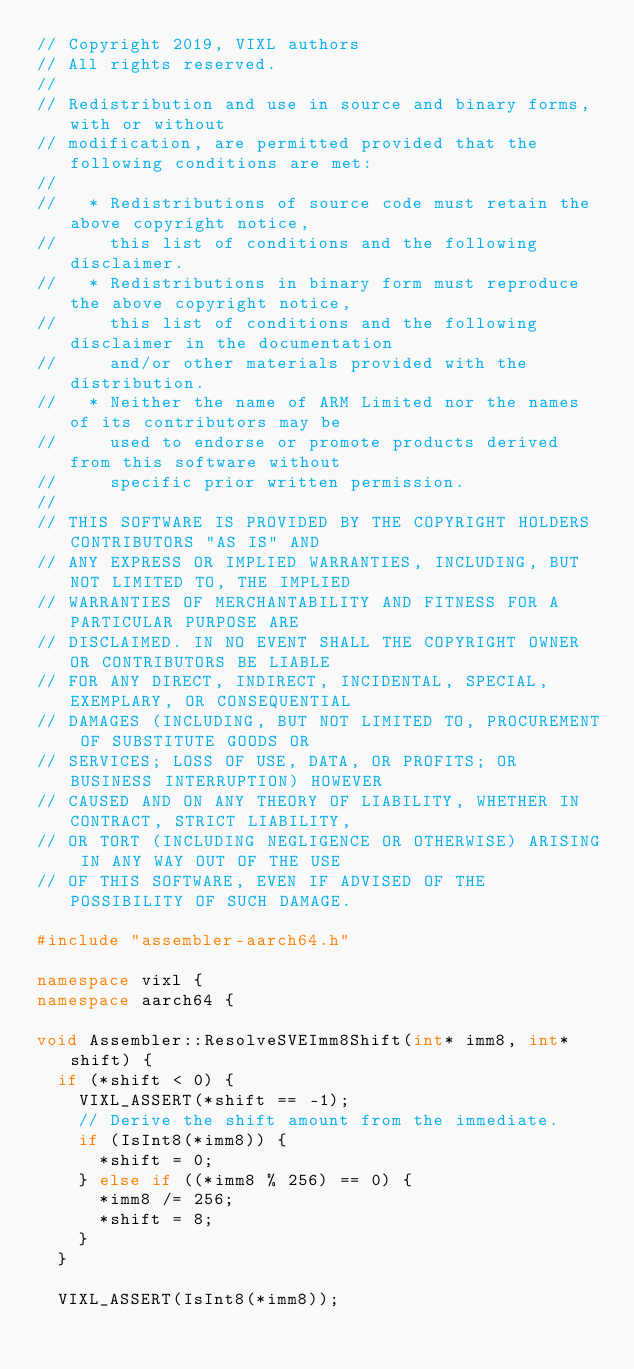<code> <loc_0><loc_0><loc_500><loc_500><_C++_>// Copyright 2019, VIXL authors
// All rights reserved.
//
// Redistribution and use in source and binary forms, with or without
// modification, are permitted provided that the following conditions are met:
//
//   * Redistributions of source code must retain the above copyright notice,
//     this list of conditions and the following disclaimer.
//   * Redistributions in binary form must reproduce the above copyright notice,
//     this list of conditions and the following disclaimer in the documentation
//     and/or other materials provided with the distribution.
//   * Neither the name of ARM Limited nor the names of its contributors may be
//     used to endorse or promote products derived from this software without
//     specific prior written permission.
//
// THIS SOFTWARE IS PROVIDED BY THE COPYRIGHT HOLDERS CONTRIBUTORS "AS IS" AND
// ANY EXPRESS OR IMPLIED WARRANTIES, INCLUDING, BUT NOT LIMITED TO, THE IMPLIED
// WARRANTIES OF MERCHANTABILITY AND FITNESS FOR A PARTICULAR PURPOSE ARE
// DISCLAIMED. IN NO EVENT SHALL THE COPYRIGHT OWNER OR CONTRIBUTORS BE LIABLE
// FOR ANY DIRECT, INDIRECT, INCIDENTAL, SPECIAL, EXEMPLARY, OR CONSEQUENTIAL
// DAMAGES (INCLUDING, BUT NOT LIMITED TO, PROCUREMENT OF SUBSTITUTE GOODS OR
// SERVICES; LOSS OF USE, DATA, OR PROFITS; OR BUSINESS INTERRUPTION) HOWEVER
// CAUSED AND ON ANY THEORY OF LIABILITY, WHETHER IN CONTRACT, STRICT LIABILITY,
// OR TORT (INCLUDING NEGLIGENCE OR OTHERWISE) ARISING IN ANY WAY OUT OF THE USE
// OF THIS SOFTWARE, EVEN IF ADVISED OF THE POSSIBILITY OF SUCH DAMAGE.

#include "assembler-aarch64.h"

namespace vixl {
namespace aarch64 {

void Assembler::ResolveSVEImm8Shift(int* imm8, int* shift) {
  if (*shift < 0) {
    VIXL_ASSERT(*shift == -1);
    // Derive the shift amount from the immediate.
    if (IsInt8(*imm8)) {
      *shift = 0;
    } else if ((*imm8 % 256) == 0) {
      *imm8 /= 256;
      *shift = 8;
    }
  }

  VIXL_ASSERT(IsInt8(*imm8));</code> 